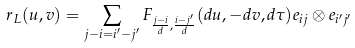<formula> <loc_0><loc_0><loc_500><loc_500>r _ { L } ( u , v ) = \sum _ { j - i = i ^ { \prime } - j ^ { \prime } } F _ { \frac { j - i } { d } , \frac { i - j ^ { \prime } } { d } } ( d u , - d v , d \tau ) e _ { i j } \otimes e _ { i ^ { \prime } j ^ { \prime } }</formula> 